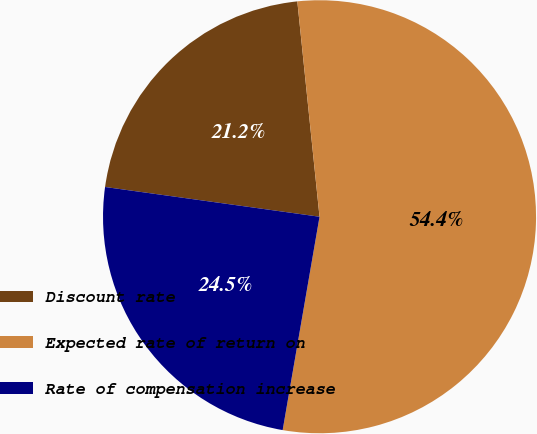<chart> <loc_0><loc_0><loc_500><loc_500><pie_chart><fcel>Discount rate<fcel>Expected rate of return on<fcel>Rate of compensation increase<nl><fcel>21.17%<fcel>54.36%<fcel>24.47%<nl></chart> 